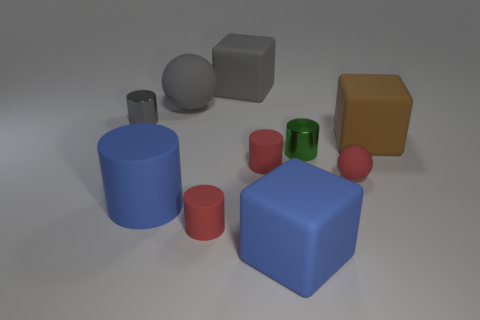Is the number of large objects that are to the left of the big brown object the same as the number of large blue metal spheres?
Offer a terse response. No. Is there any other thing that is made of the same material as the big gray block?
Ensure brevity in your answer.  Yes. Does the big rubber ball have the same color as the tiny object behind the small green thing?
Your answer should be very brief. Yes. Are there any large gray matte objects that are in front of the big rubber cube that is behind the cylinder behind the brown cube?
Keep it short and to the point. Yes. Is the number of blue things on the right side of the large brown cube less than the number of small green rubber cylinders?
Offer a very short reply. No. What number of other objects are there of the same shape as the brown matte thing?
Keep it short and to the point. 2. How many things are either objects behind the big brown matte block or large gray rubber things behind the gray sphere?
Provide a short and direct response. 3. How big is the block that is both behind the red rubber sphere and left of the large brown object?
Offer a terse response. Large. Do the small metallic thing behind the brown thing and the brown thing have the same shape?
Keep it short and to the point. No. What size is the blue cube that is left of the metal cylinder that is in front of the large rubber cube that is right of the small green cylinder?
Ensure brevity in your answer.  Large. 